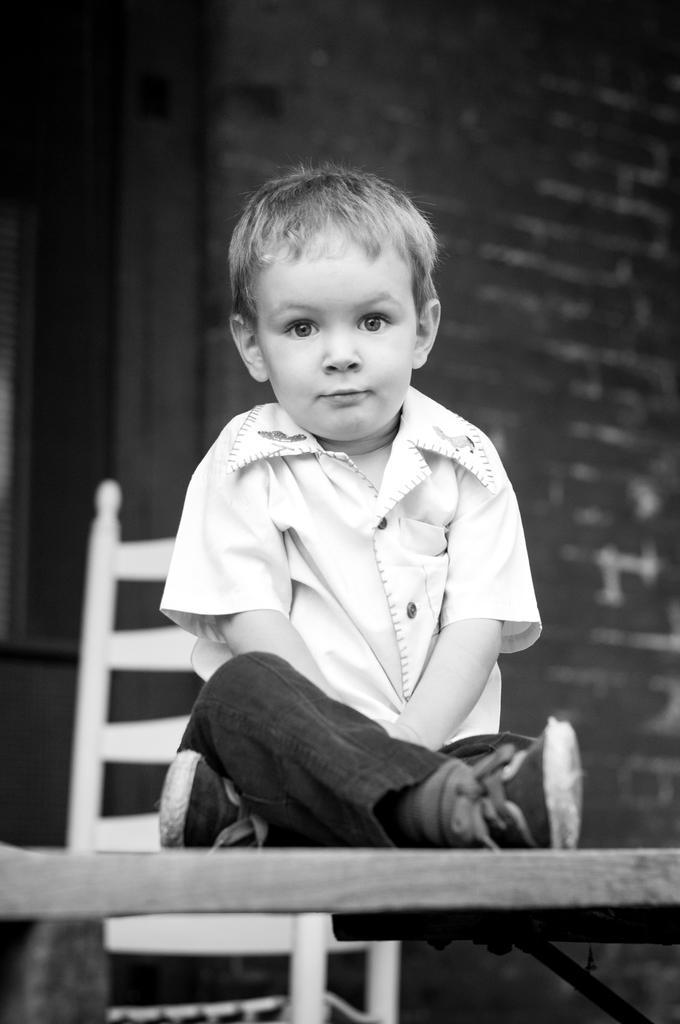In one or two sentences, can you explain what this image depicts? In this picture we can see a boy sitting on the table. We can see a chair and a building in the background. 